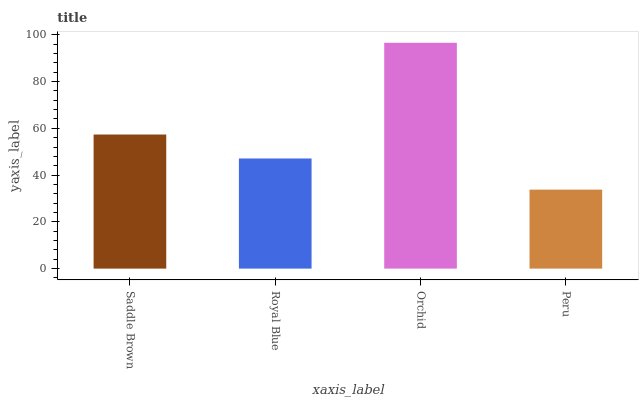Is Peru the minimum?
Answer yes or no. Yes. Is Orchid the maximum?
Answer yes or no. Yes. Is Royal Blue the minimum?
Answer yes or no. No. Is Royal Blue the maximum?
Answer yes or no. No. Is Saddle Brown greater than Royal Blue?
Answer yes or no. Yes. Is Royal Blue less than Saddle Brown?
Answer yes or no. Yes. Is Royal Blue greater than Saddle Brown?
Answer yes or no. No. Is Saddle Brown less than Royal Blue?
Answer yes or no. No. Is Saddle Brown the high median?
Answer yes or no. Yes. Is Royal Blue the low median?
Answer yes or no. Yes. Is Orchid the high median?
Answer yes or no. No. Is Peru the low median?
Answer yes or no. No. 